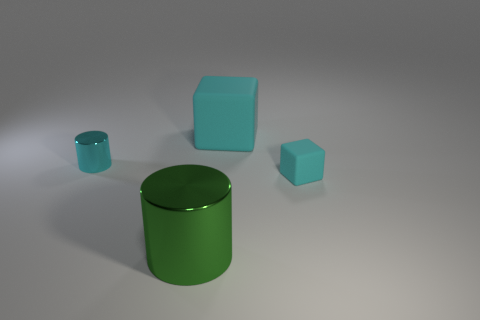Add 4 metal objects. How many objects exist? 8 Add 3 shiny cubes. How many shiny cubes exist? 3 Subtract 0 brown cylinders. How many objects are left? 4 Subtract all tiny metallic cylinders. Subtract all large green metallic things. How many objects are left? 2 Add 4 tiny matte blocks. How many tiny matte blocks are left? 5 